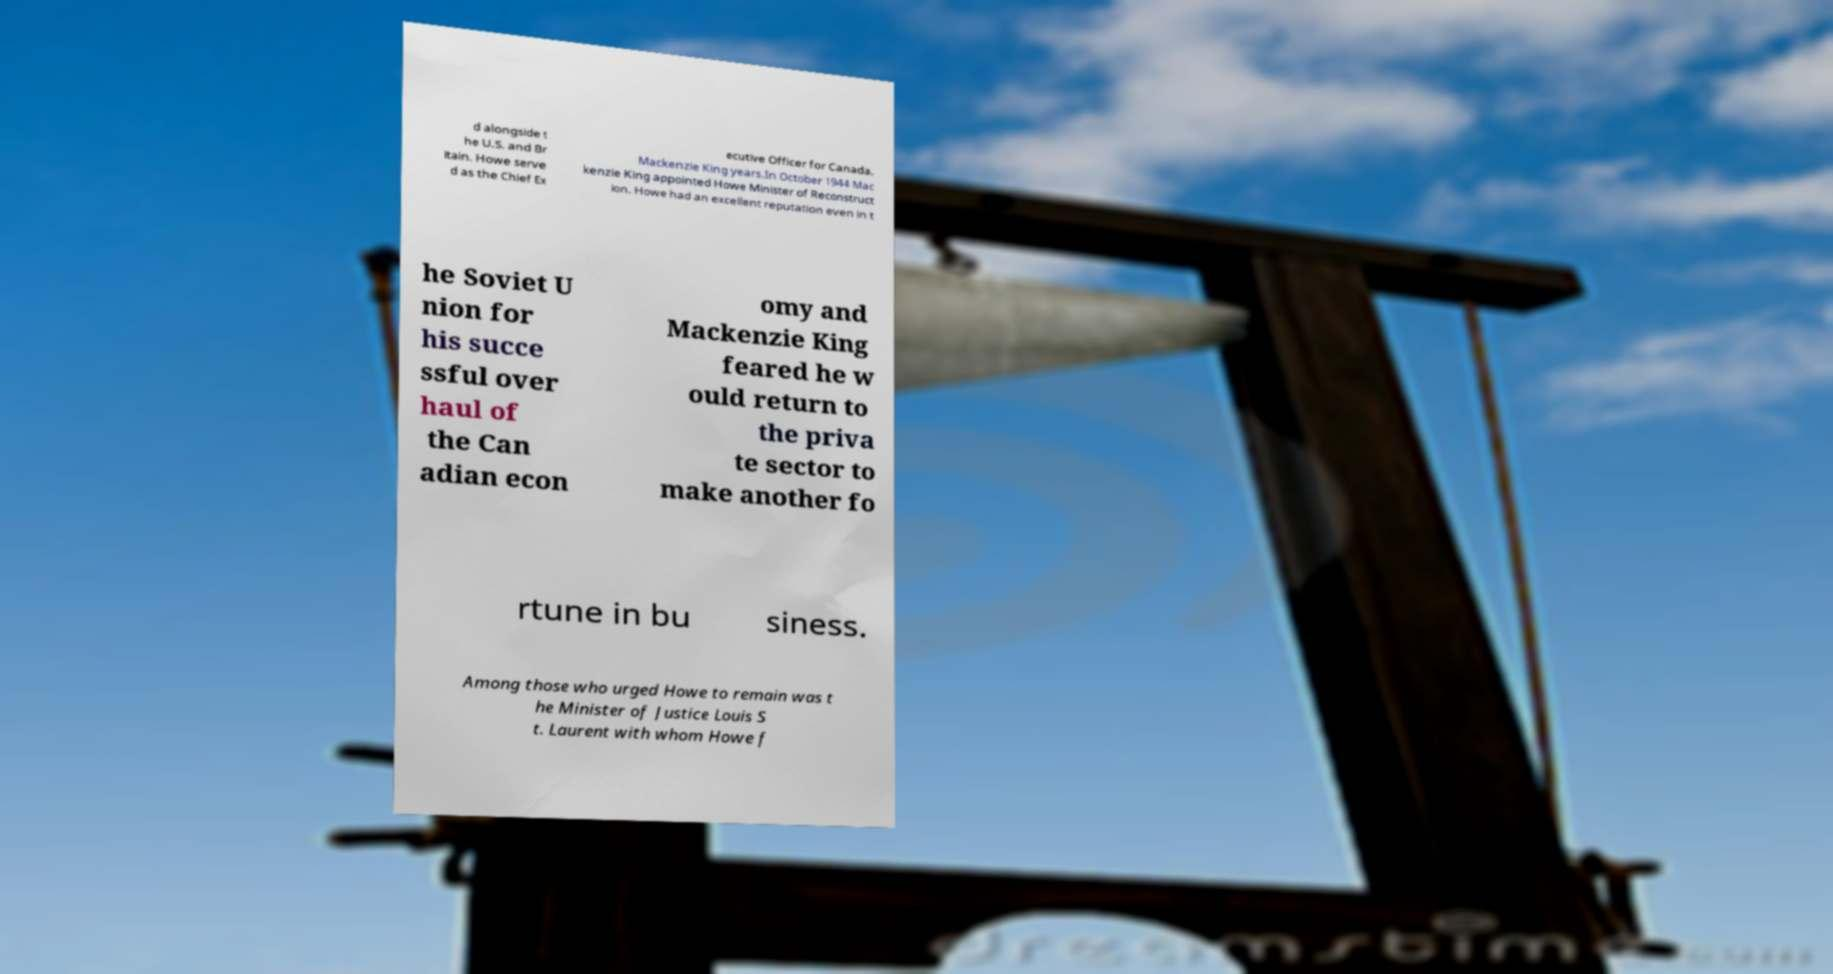There's text embedded in this image that I need extracted. Can you transcribe it verbatim? d alongside t he U.S. and Br itain. Howe serve d as the Chief Ex ecutive Officer for Canada. Mackenzie King years.In October 1944 Mac kenzie King appointed Howe Minister of Reconstruct ion. Howe had an excellent reputation even in t he Soviet U nion for his succe ssful over haul of the Can adian econ omy and Mackenzie King feared he w ould return to the priva te sector to make another fo rtune in bu siness. Among those who urged Howe to remain was t he Minister of Justice Louis S t. Laurent with whom Howe f 